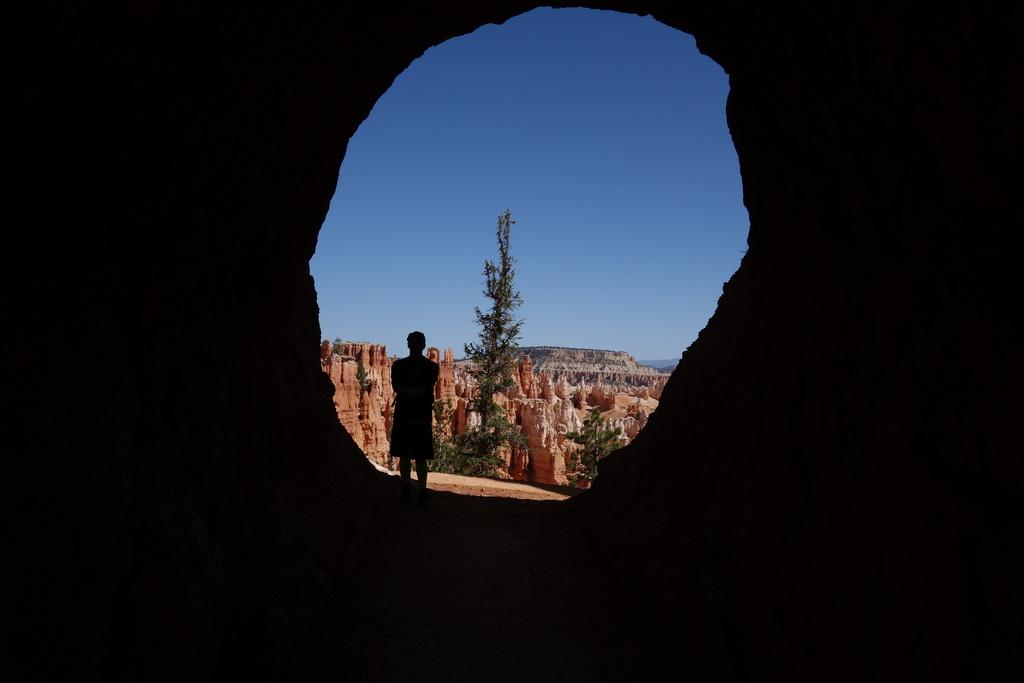What is the main feature of the image that creates a hole-like shape? There is a hole in the image. What can be seen through the hole? A person is visible through the hole. What type of natural elements are present in the image? There are trees and plants in the image. What type of structure is present in the image? There is a fort in the image. What is visible in the background of the image? The sky is visible in the background of the image. What type of nerve can be seen in the image? There is no nerve present in the image. Can you describe the twig that the person is holding in the image? There is no twig visible in the image, nor is there any indication that the person is holding anything. 